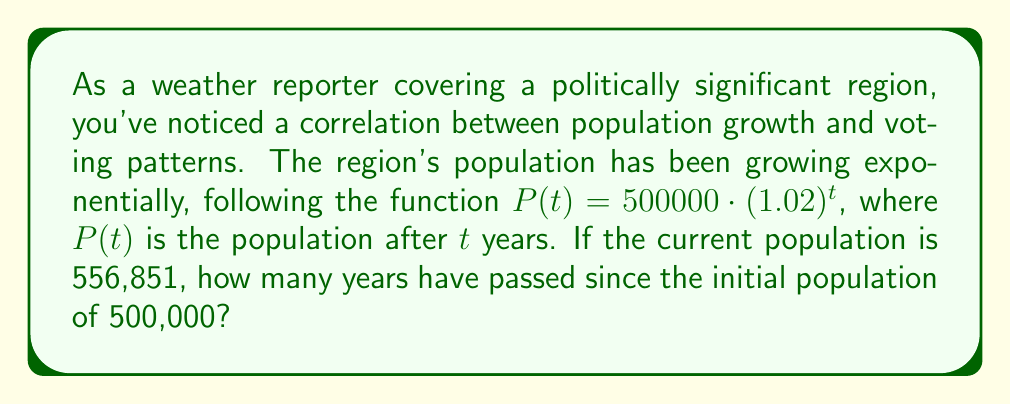Could you help me with this problem? Let's approach this step-by-step:

1) We're given the exponential growth function: $P(t) = 500000 \cdot (1.02)^t$

2) We know the current population is 556,851. Let's substitute this into our equation:

   $556851 = 500000 \cdot (1.02)^t$

3) To solve for $t$, let's first divide both sides by 500000:

   $\frac{556851}{500000} = (1.02)^t$

4) This simplifies to:

   $1.11370 = (1.02)^t$

5) To solve for $t$, we need to take the logarithm of both sides. We can use any base, but let's use base 10:

   $\log_{10}(1.11370) = \log_{10}((1.02)^t)$

6) Using the logarithm property $\log_a(x^n) = n\log_a(x)$, we get:

   $\log_{10}(1.11370) = t \cdot \log_{10}(1.02)$

7) Now we can solve for $t$:

   $t = \frac{\log_{10}(1.11370)}{\log_{10}(1.02)}$

8) Using a calculator:

   $t = \frac{0.04686}{0.00860} \approx 5.45$

9) Since we're dealing with years, we need to round to the nearest whole number:

   $t = 5$ years
Answer: 5 years 